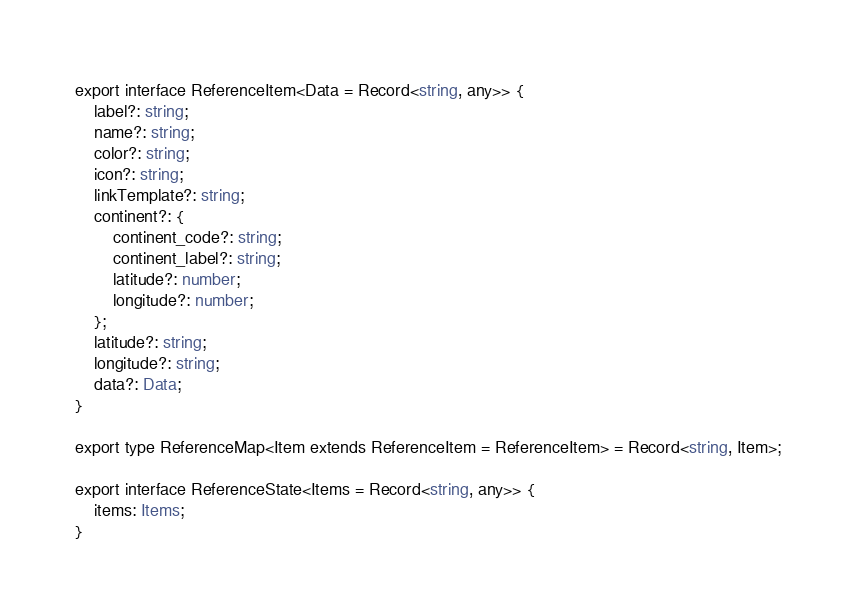Convert code to text. <code><loc_0><loc_0><loc_500><loc_500><_TypeScript_>export interface ReferenceItem<Data = Record<string, any>> {
    label?: string;
    name?: string;
    color?: string;
    icon?: string;
    linkTemplate?: string;
    continent?: {
        continent_code?: string;
        continent_label?: string;
        latitude?: number;
        longitude?: number;
    };
    latitude?: string;
    longitude?: string;
    data?: Data;
}

export type ReferenceMap<Item extends ReferenceItem = ReferenceItem> = Record<string, Item>;

export interface ReferenceState<Items = Record<string, any>> {
    items: Items;
}
</code> 